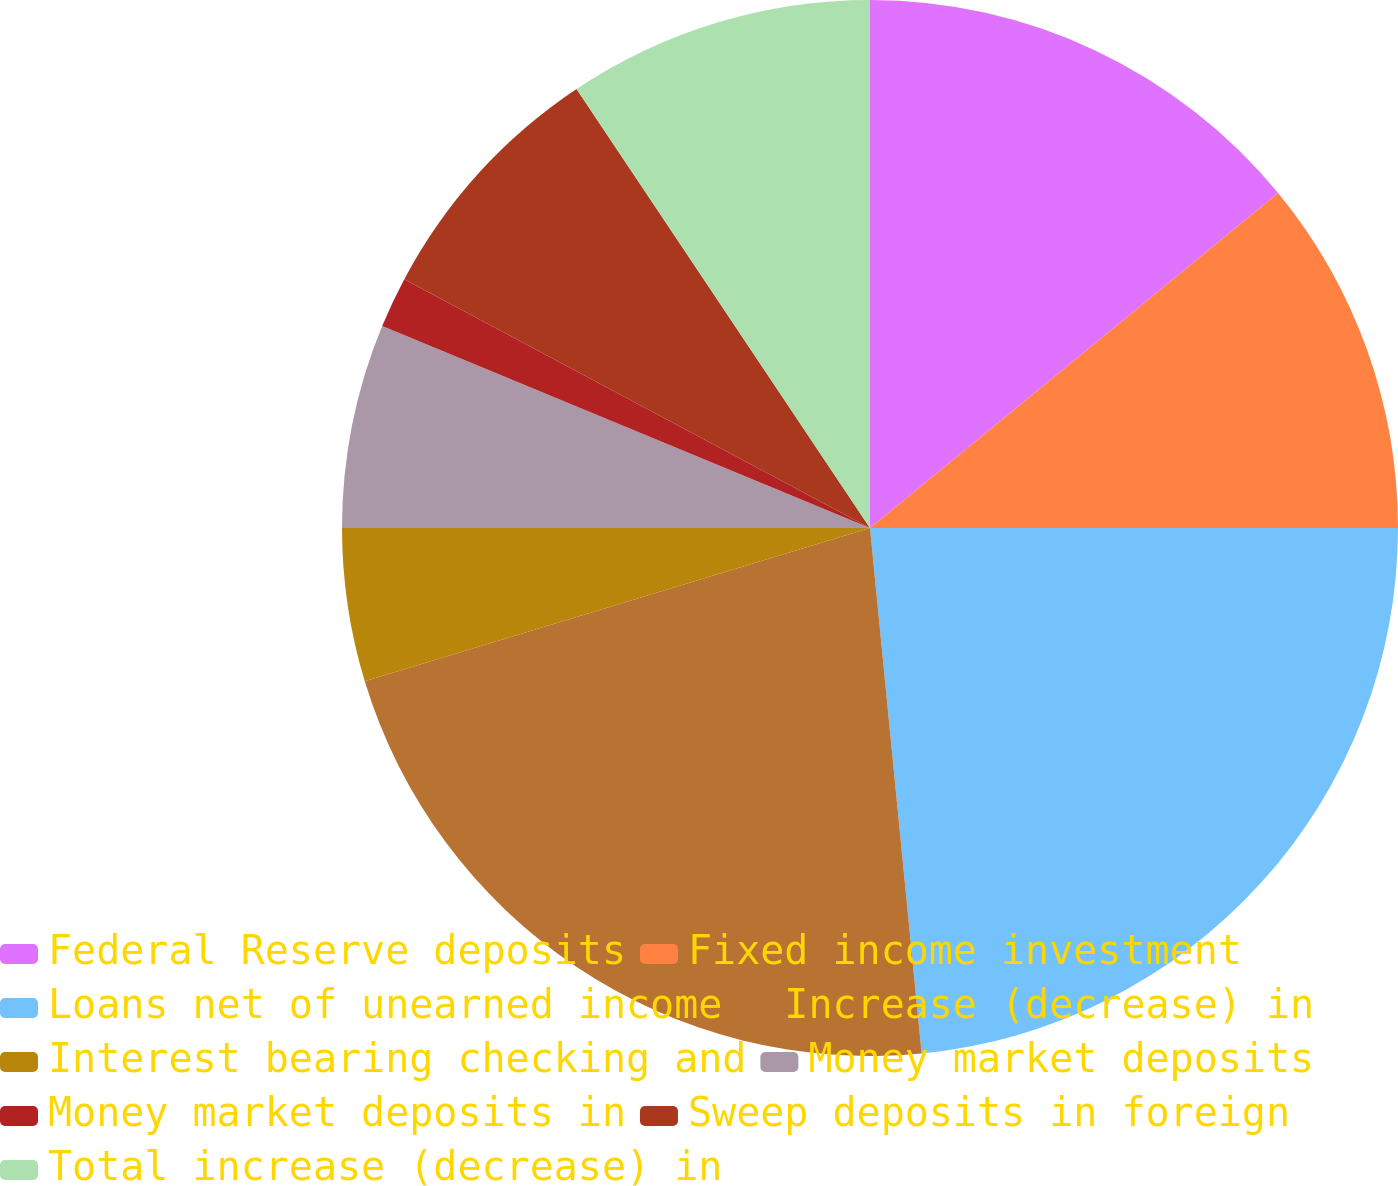<chart> <loc_0><loc_0><loc_500><loc_500><pie_chart><fcel>Federal Reserve deposits<fcel>Fixed income investment<fcel>Loans net of unearned income<fcel>Increase (decrease) in<fcel>Interest bearing checking and<fcel>Money market deposits<fcel>Money market deposits in<fcel>Sweep deposits in foreign<fcel>Total increase (decrease) in<nl><fcel>14.06%<fcel>10.94%<fcel>23.44%<fcel>21.87%<fcel>4.69%<fcel>6.25%<fcel>1.56%<fcel>7.81%<fcel>9.38%<nl></chart> 